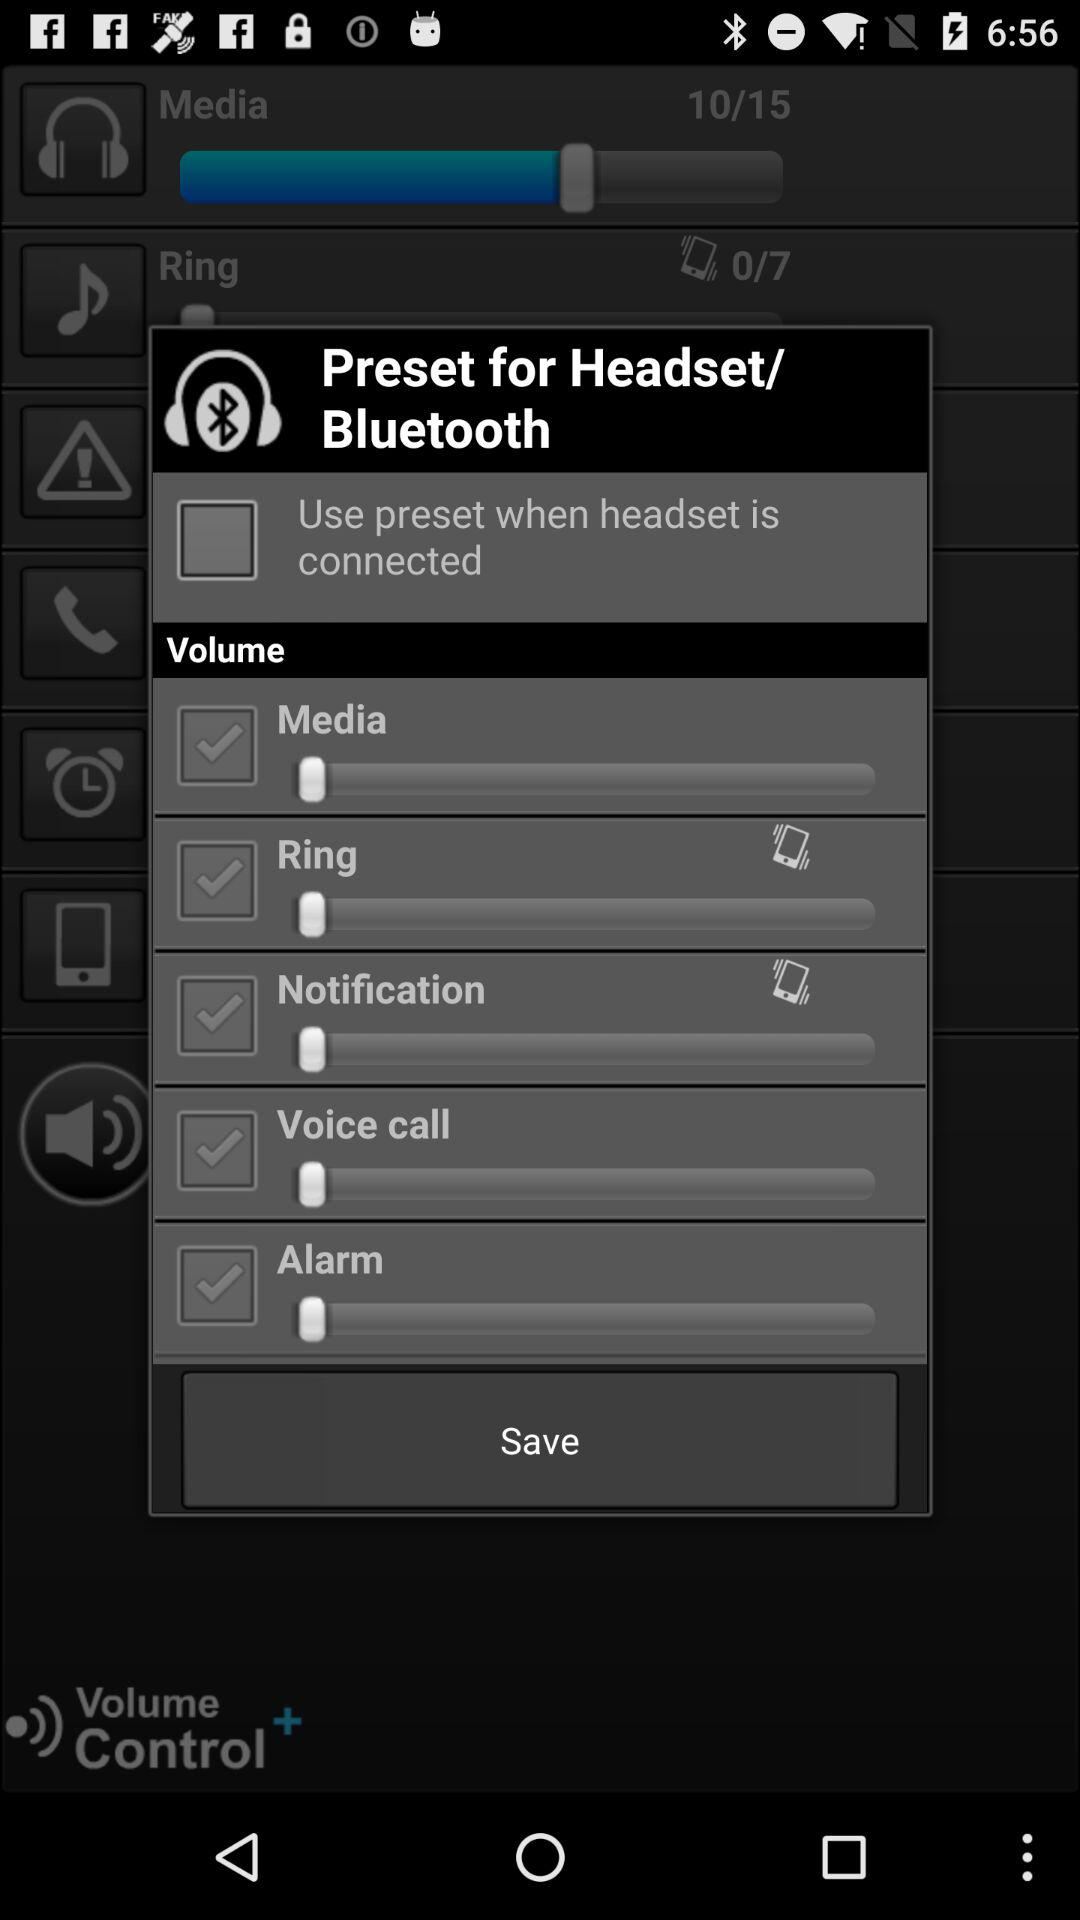What is the status of media volume? The status is "off". 